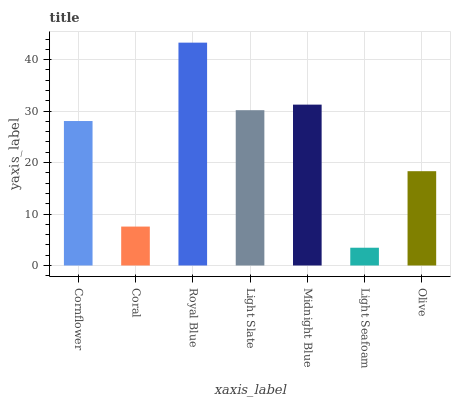Is Coral the minimum?
Answer yes or no. No. Is Coral the maximum?
Answer yes or no. No. Is Cornflower greater than Coral?
Answer yes or no. Yes. Is Coral less than Cornflower?
Answer yes or no. Yes. Is Coral greater than Cornflower?
Answer yes or no. No. Is Cornflower less than Coral?
Answer yes or no. No. Is Cornflower the high median?
Answer yes or no. Yes. Is Cornflower the low median?
Answer yes or no. Yes. Is Olive the high median?
Answer yes or no. No. Is Light Seafoam the low median?
Answer yes or no. No. 